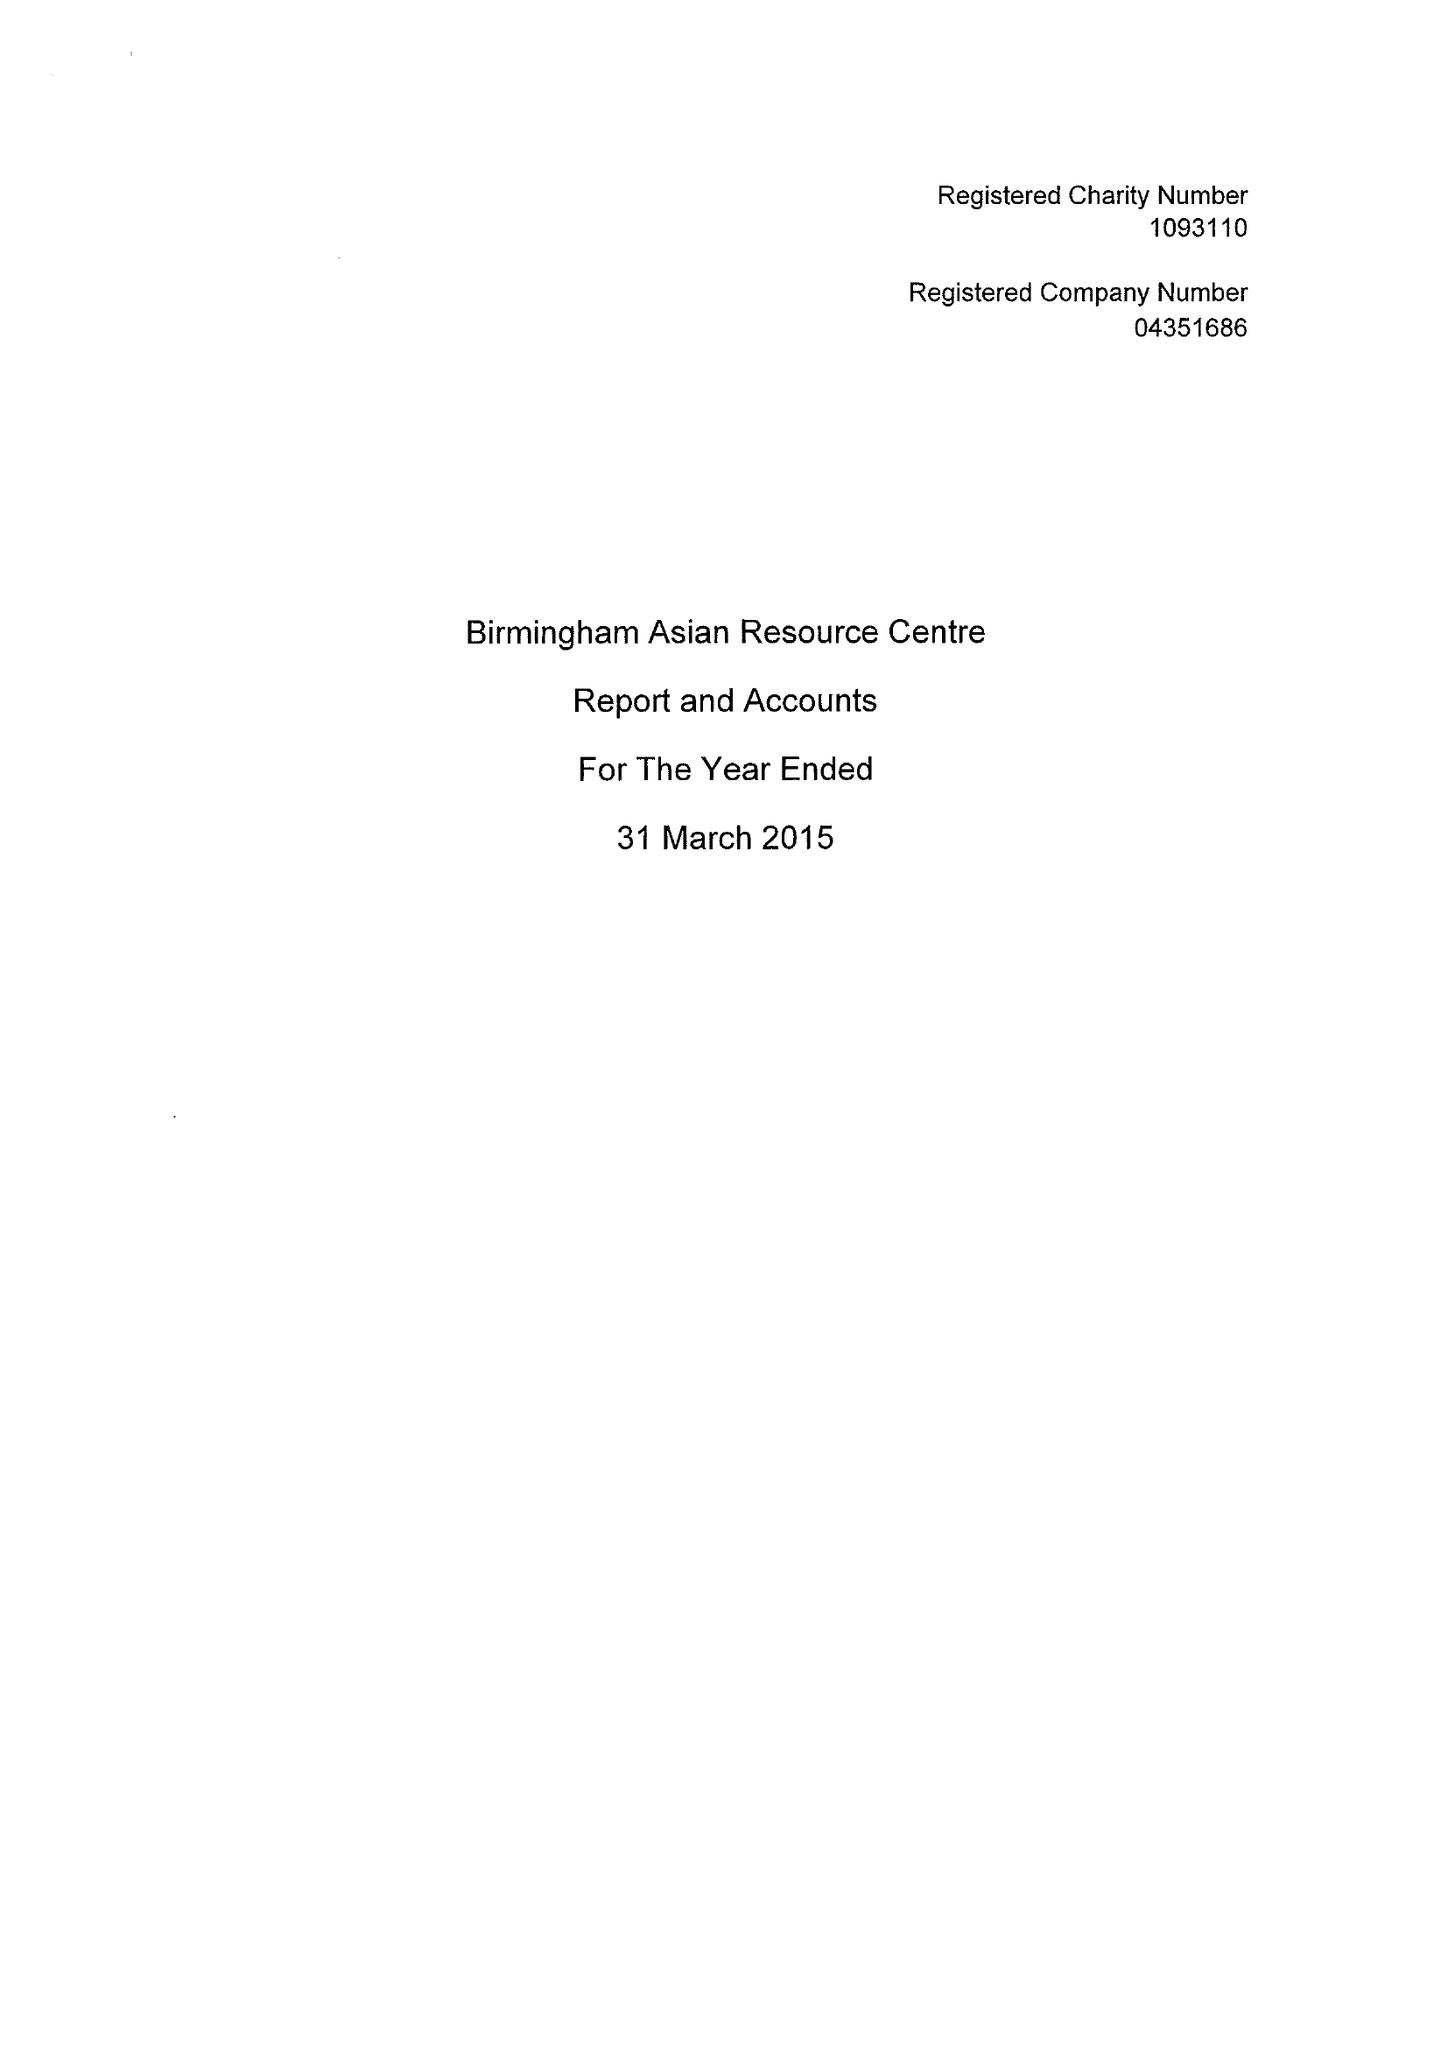What is the value for the charity_number?
Answer the question using a single word or phrase. 1093110 